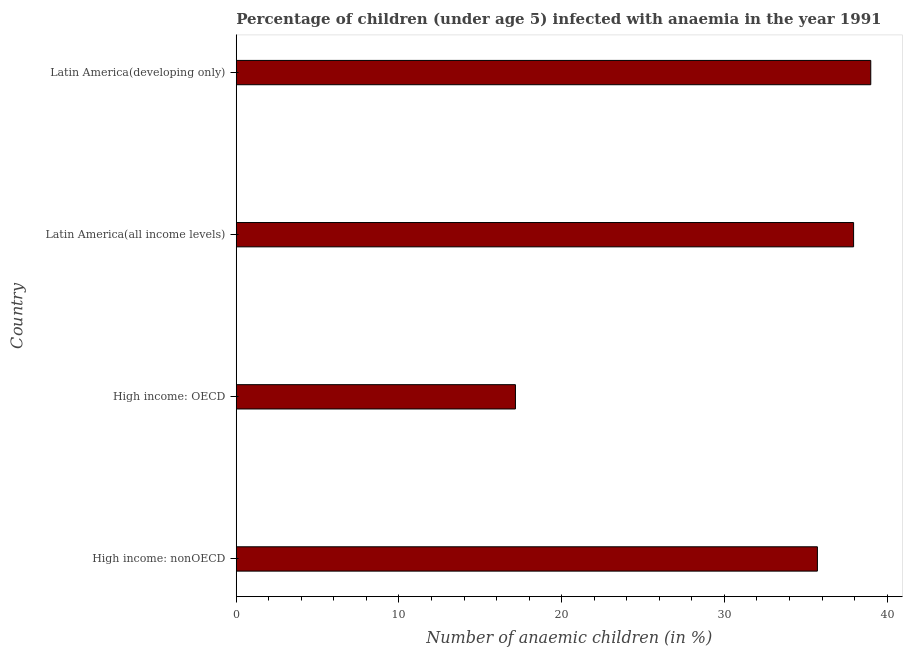What is the title of the graph?
Provide a short and direct response. Percentage of children (under age 5) infected with anaemia in the year 1991. What is the label or title of the X-axis?
Your answer should be very brief. Number of anaemic children (in %). What is the label or title of the Y-axis?
Keep it short and to the point. Country. What is the number of anaemic children in High income: nonOECD?
Keep it short and to the point. 35.72. Across all countries, what is the maximum number of anaemic children?
Make the answer very short. 38.99. Across all countries, what is the minimum number of anaemic children?
Keep it short and to the point. 17.16. In which country was the number of anaemic children maximum?
Your answer should be very brief. Latin America(developing only). In which country was the number of anaemic children minimum?
Provide a short and direct response. High income: OECD. What is the sum of the number of anaemic children?
Keep it short and to the point. 129.81. What is the difference between the number of anaemic children in High income: OECD and High income: nonOECD?
Provide a short and direct response. -18.56. What is the average number of anaemic children per country?
Offer a very short reply. 32.45. What is the median number of anaemic children?
Your answer should be very brief. 36.83. What is the ratio of the number of anaemic children in Latin America(all income levels) to that in Latin America(developing only)?
Provide a succinct answer. 0.97. Is the difference between the number of anaemic children in High income: nonOECD and Latin America(developing only) greater than the difference between any two countries?
Your answer should be compact. No. What is the difference between the highest and the second highest number of anaemic children?
Offer a very short reply. 1.05. What is the difference between the highest and the lowest number of anaemic children?
Your response must be concise. 21.84. In how many countries, is the number of anaemic children greater than the average number of anaemic children taken over all countries?
Your response must be concise. 3. Are all the bars in the graph horizontal?
Offer a very short reply. Yes. What is the difference between two consecutive major ticks on the X-axis?
Offer a terse response. 10. What is the Number of anaemic children (in %) of High income: nonOECD?
Your response must be concise. 35.72. What is the Number of anaemic children (in %) of High income: OECD?
Your answer should be very brief. 17.16. What is the Number of anaemic children (in %) of Latin America(all income levels)?
Give a very brief answer. 37.94. What is the Number of anaemic children (in %) of Latin America(developing only)?
Offer a terse response. 38.99. What is the difference between the Number of anaemic children (in %) in High income: nonOECD and High income: OECD?
Offer a terse response. 18.56. What is the difference between the Number of anaemic children (in %) in High income: nonOECD and Latin America(all income levels)?
Provide a short and direct response. -2.22. What is the difference between the Number of anaemic children (in %) in High income: nonOECD and Latin America(developing only)?
Your response must be concise. -3.28. What is the difference between the Number of anaemic children (in %) in High income: OECD and Latin America(all income levels)?
Your answer should be compact. -20.78. What is the difference between the Number of anaemic children (in %) in High income: OECD and Latin America(developing only)?
Provide a succinct answer. -21.84. What is the difference between the Number of anaemic children (in %) in Latin America(all income levels) and Latin America(developing only)?
Keep it short and to the point. -1.06. What is the ratio of the Number of anaemic children (in %) in High income: nonOECD to that in High income: OECD?
Keep it short and to the point. 2.08. What is the ratio of the Number of anaemic children (in %) in High income: nonOECD to that in Latin America(all income levels)?
Keep it short and to the point. 0.94. What is the ratio of the Number of anaemic children (in %) in High income: nonOECD to that in Latin America(developing only)?
Give a very brief answer. 0.92. What is the ratio of the Number of anaemic children (in %) in High income: OECD to that in Latin America(all income levels)?
Ensure brevity in your answer.  0.45. What is the ratio of the Number of anaemic children (in %) in High income: OECD to that in Latin America(developing only)?
Your answer should be compact. 0.44. What is the ratio of the Number of anaemic children (in %) in Latin America(all income levels) to that in Latin America(developing only)?
Provide a short and direct response. 0.97. 